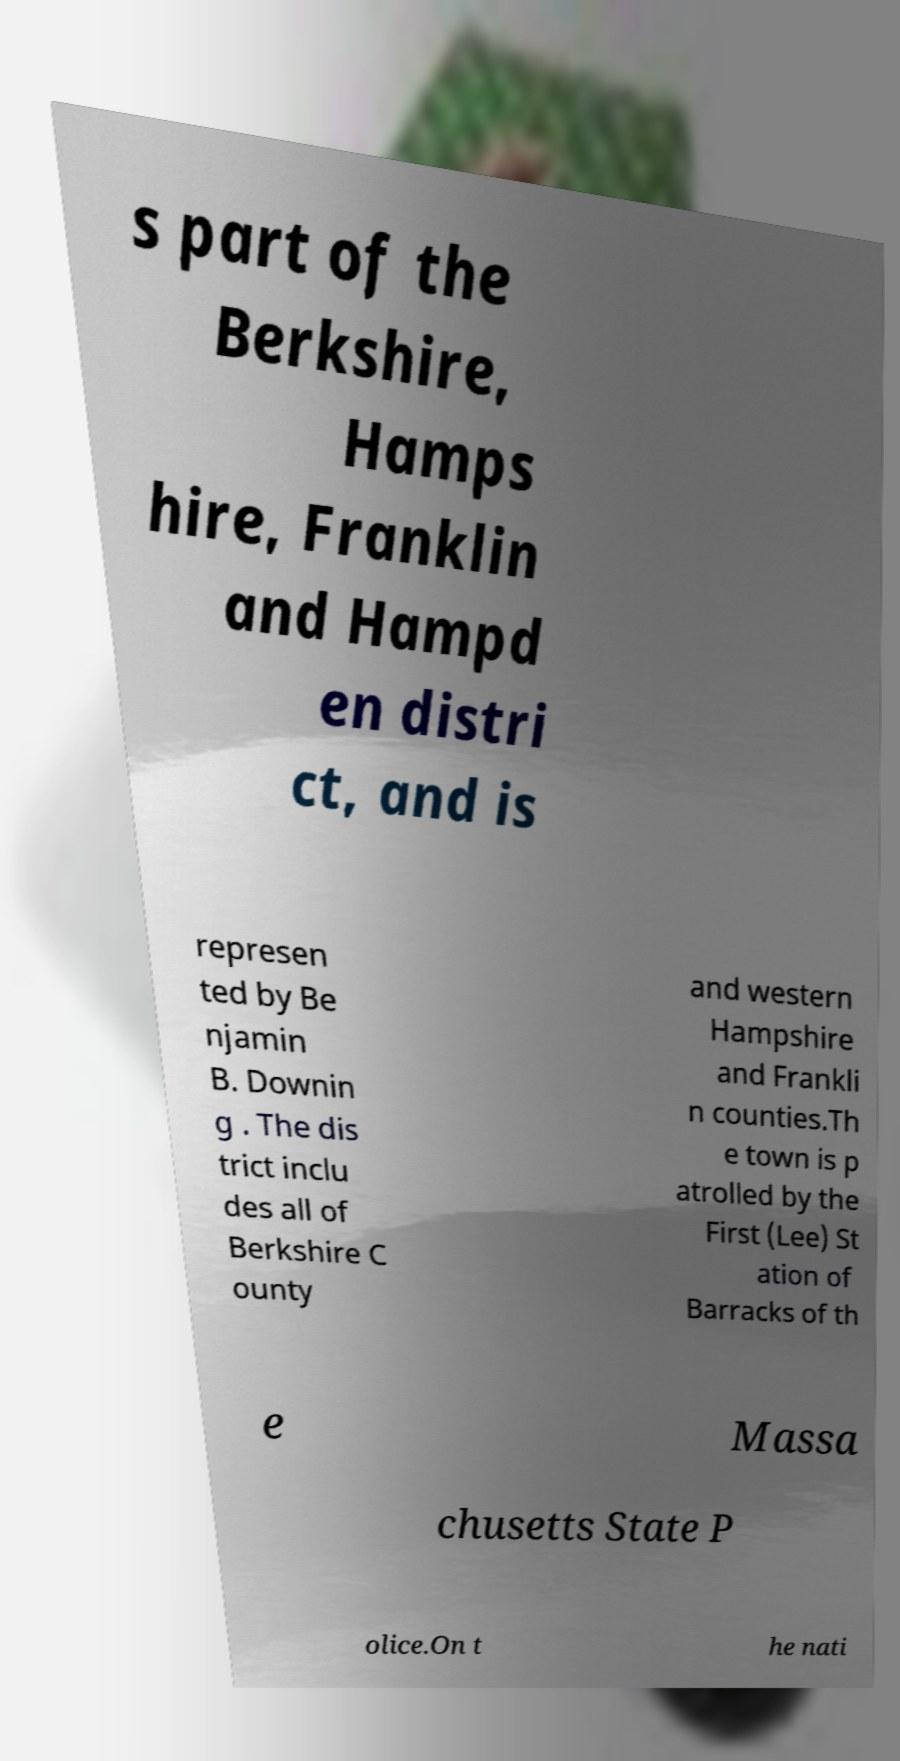There's text embedded in this image that I need extracted. Can you transcribe it verbatim? s part of the Berkshire, Hamps hire, Franklin and Hampd en distri ct, and is represen ted by Be njamin B. Downin g . The dis trict inclu des all of Berkshire C ounty and western Hampshire and Frankli n counties.Th e town is p atrolled by the First (Lee) St ation of Barracks of th e Massa chusetts State P olice.On t he nati 